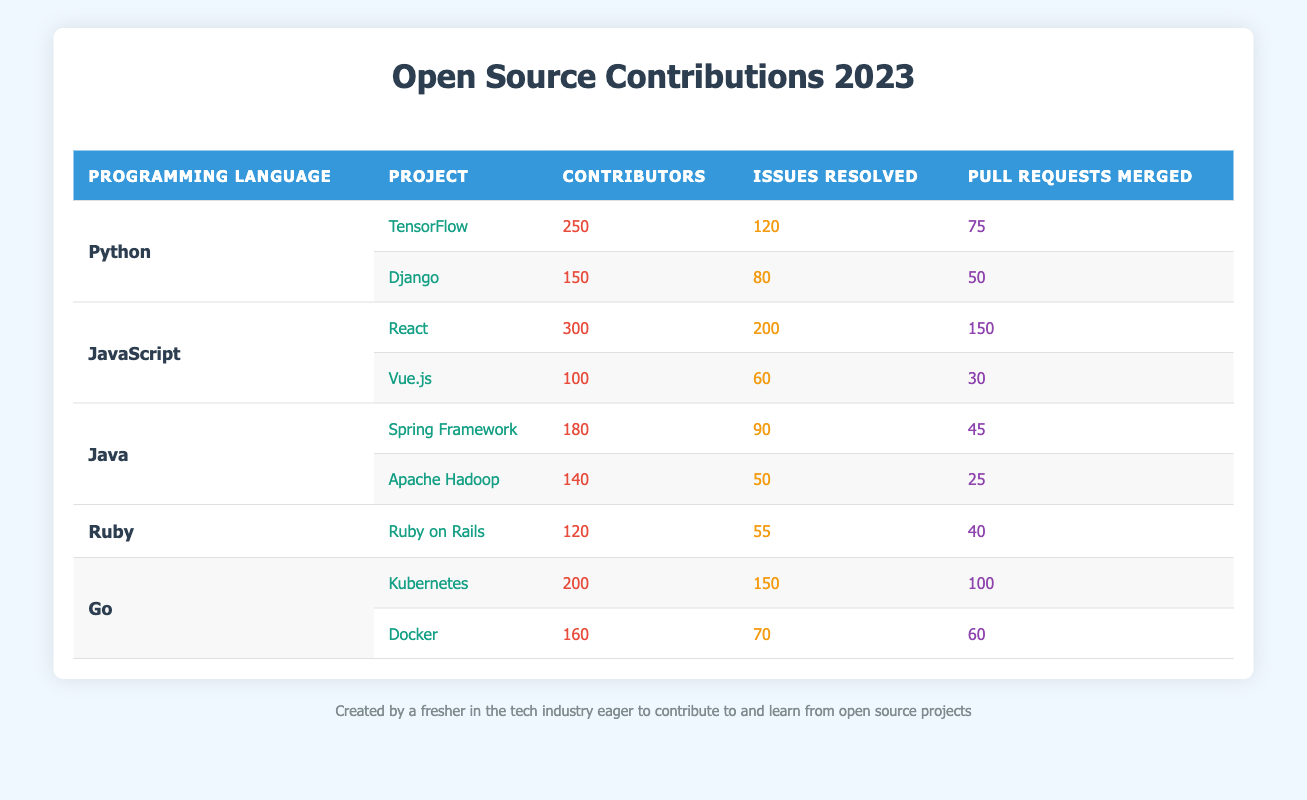What is the total number of contributors for Python projects? The total number of contributors for Python projects includes the contributors from both TensorFlow and Django. TensorFlow has 250 contributors and Django has 150 contributors. Therefore, the total is 250 + 150 = 400.
Answer: 400 Which Java project has the highest number of issues resolved? The Java projects listed are Spring Framework and Apache Hadoop. Spring Framework has 90 issues resolved, while Apache Hadoop has 50. Since 90 is greater than 50, Spring Framework has the highest number of issues resolved.
Answer: Spring Framework Is the number of Pull Requests Merged in React greater than the total number of Pull Requests Merged in all Python projects? To find the answer, we first note that React has 150 Pull Requests Merged. The total Pull Requests Merged in Python projects is 75 (TensorFlow) + 50 (Django) = 125. Since 150 is greater than 125, the statement is true.
Answer: Yes What is the average number of Pull Requests Merged across all projects listed in the table? We first add up the Pull Requests Merged: TensorFlow (75) + Django (50) + React (150) + Vue.js (30) + Spring Framework (45) + Apache Hadoop (25) + Ruby on Rails (40) + Kubernetes (100) + Docker (60) = 530. There are 9 projects total, so we find the average by dividing by 9: 530 / 9 = 58.89.
Answer: 58.89 Which programming language has the least number of contributors? We compare the total contributors across all languages: Python (400), JavaScript (400), Java (320), Ruby (120), and Go (360). Ruby has the least number of contributors with only 120.
Answer: Ruby 